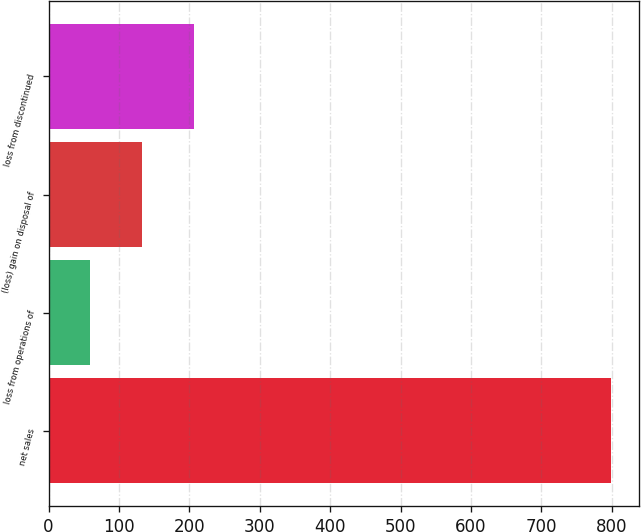Convert chart. <chart><loc_0><loc_0><loc_500><loc_500><bar_chart><fcel>net sales<fcel>loss from operations of<fcel>(loss) gain on disposal of<fcel>loss from discontinued<nl><fcel>798.2<fcel>58.2<fcel>132.2<fcel>206.2<nl></chart> 